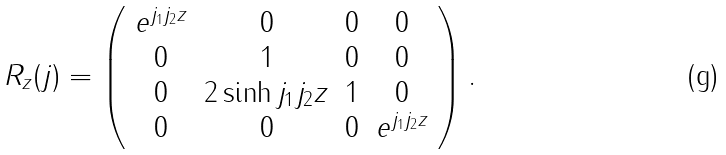Convert formula to latex. <formula><loc_0><loc_0><loc_500><loc_500>R _ { z } ( { j } ) = \left ( \begin{array} { c c c c } e ^ { j _ { 1 } j _ { 2 } z } & 0 & 0 & 0 \\ 0 & 1 & 0 & 0 \\ 0 & 2 \sinh { j _ { 1 } j _ { 2 } z } & 1 & 0 \\ 0 & 0 & 0 & e ^ { j _ { 1 } j _ { 2 } z } \end{array} \right ) .</formula> 